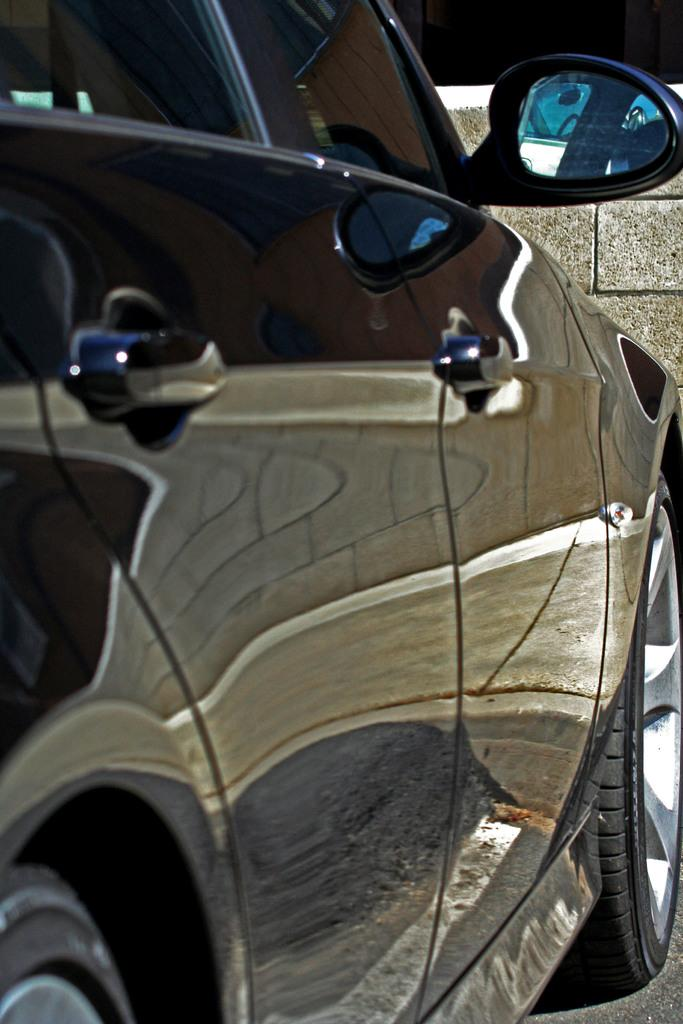What is the main subject of the image? The main subject of the image is a car. Can you describe the appearance of the car in the image? The car is truncated or partially visible in the image. What type of lift is installed in the car in the image? There is no lift present in the car in the image, as it is truncated or partially visible. What type of plough is attached to the front of the car in the image? There is no plough present in the image, as it only shows a car that is partially visible. 